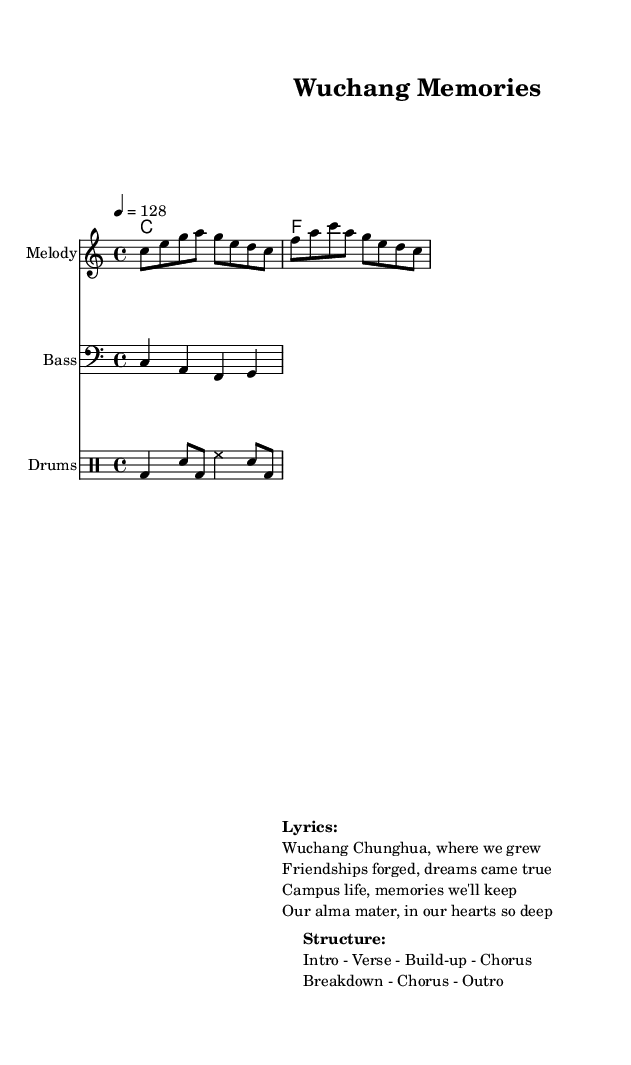What is the key signature of this music? The key signature is indicated at the beginning of the music staff. In this case, it is marked as C major, which means there are no sharps or flats.
Answer: C major What is the time signature of this music? The time signature is found on the left side of the score, reported as 4/4. This indicates there are four beats in a measure and the quarter note gets one beat.
Answer: 4/4 What is the tempo of this piece? The tempo marking is given as "4 = 128," indicating that there are 128 beats per minute when counting quarter notes. This shows the piece is intended to be played at a lively pace.
Answer: 128 How many sections are outlined in the structure? The structure of the piece contains six uniquely identified sections: Intro, Verse, Build-up, Chorus, Breakdown, and Outro. By counting these sections, the number can be determined.
Answer: 6 What is the instrument name for the melody in this score? The instrument name for the melody is specified in the staff header, which is labeled as "Melody." This identifies the specific part designated for the main melodic line.
Answer: Melody What type of drums are indicated in the drum staff? In the drum staff, there are specific notations that indicate kick drums (bd), snare (sn), and hi-hat (hh). Identifying these sounds from the notation gives clarity on the drum sounds used in this piece.
Answer: Kick, snare, hi-hat What are the lyrics celebrating? The lyrics celebrate the experiences and friendships forged during university life at Wuchang Chunghua, emphasizing the memories related to their alma mater. This thematic content reflects the essence of university life.
Answer: University life and friendships 